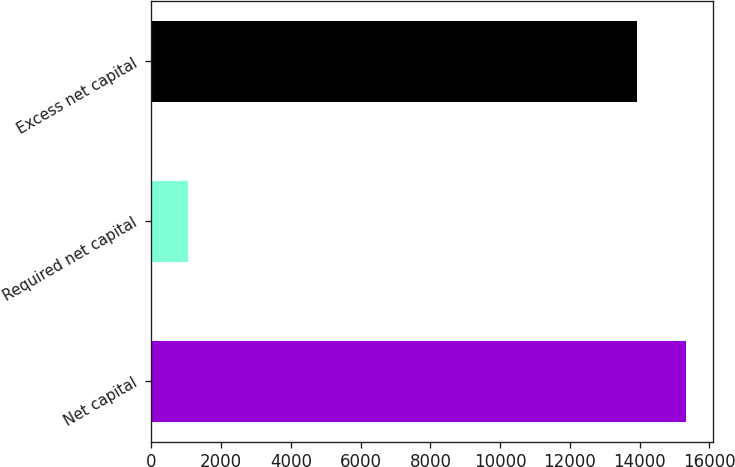Convert chart to OTSL. <chart><loc_0><loc_0><loc_500><loc_500><bar_chart><fcel>Net capital<fcel>Required net capital<fcel>Excess net capital<nl><fcel>15327.4<fcel>1048<fcel>13934<nl></chart> 